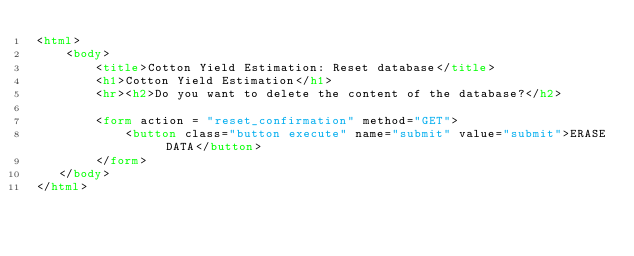Convert code to text. <code><loc_0><loc_0><loc_500><loc_500><_HTML_><html>
    <body>
        <title>Cotton Yield Estimation: Reset database</title>
        <h1>Cotton Yield Estimation</h1> 
        <hr><h2>Do you want to delete the content of the database?</h2>

        <form action = "reset_confirmation" method="GET">
            <button class="button execute" name="submit" value="submit">ERASE DATA</button>
        </form>
   </body>
</html></code> 